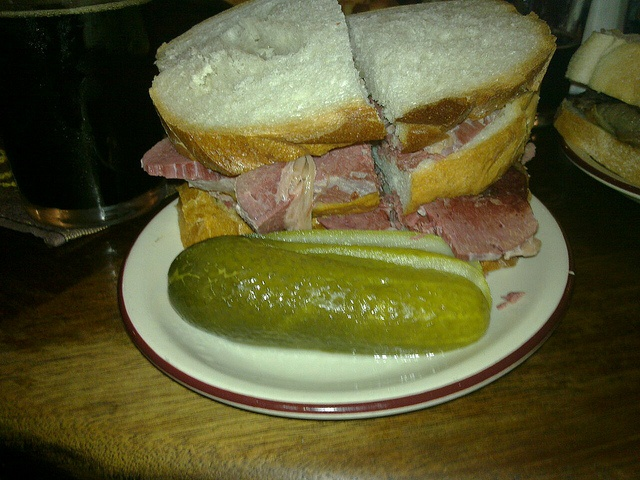Describe the objects in this image and their specific colors. I can see dining table in black, olive, darkgray, and maroon tones, sandwich in black, darkgray, olive, and gray tones, cup in black, darkgreen, and maroon tones, and sandwich in black and olive tones in this image. 